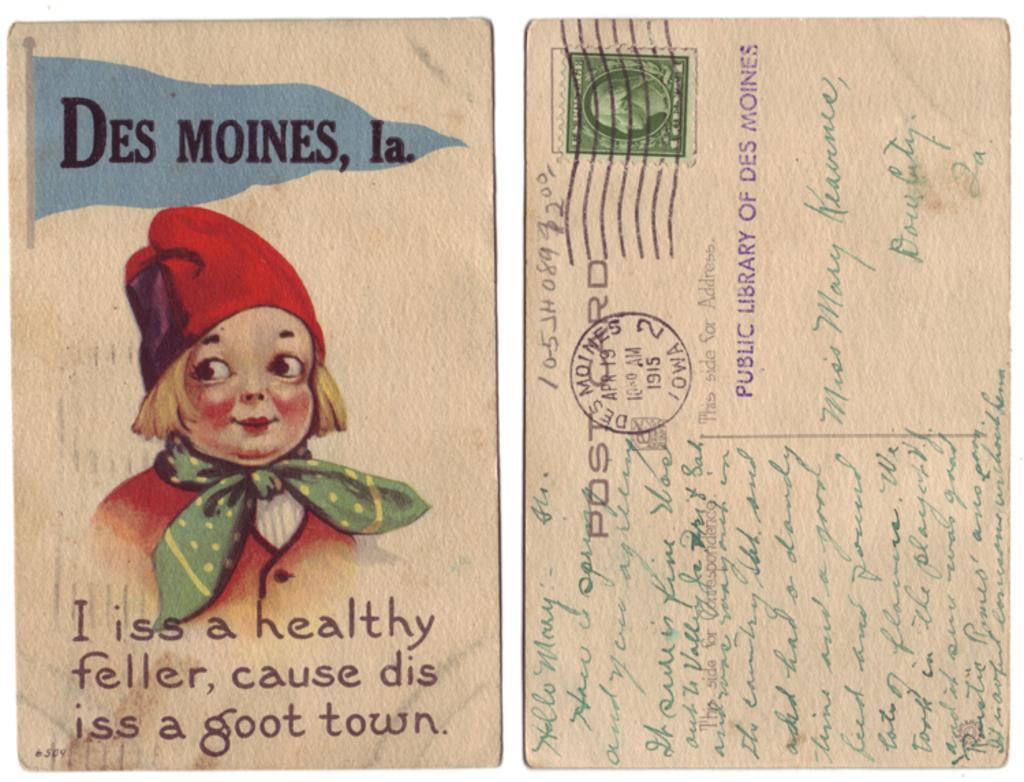How would you summarize this image in a sentence or two? In this image, we can see a paper, on that paper, we can see a picture and some text. 